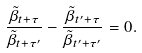<formula> <loc_0><loc_0><loc_500><loc_500>\frac { \tilde { \beta } _ { t + \tau } } { \tilde { \beta } _ { t + \tau ^ { \prime } } } - \frac { \tilde { \beta } _ { t ^ { \prime } + \tau } } { \tilde { \beta } _ { t ^ { \prime } + \tau ^ { \prime } } } = 0 .</formula> 